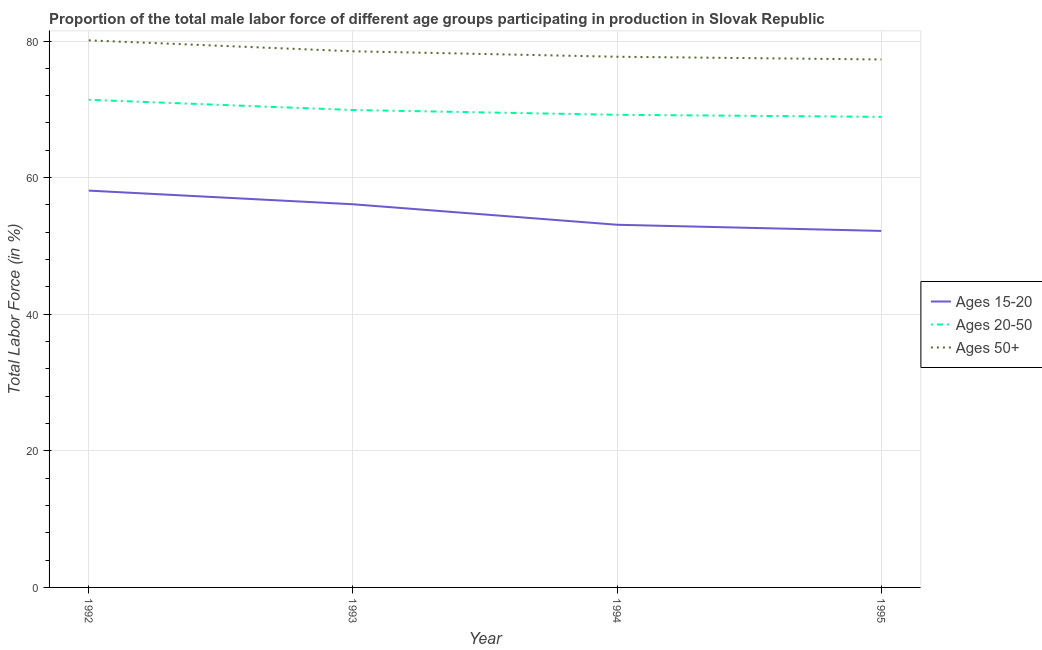Is the number of lines equal to the number of legend labels?
Offer a very short reply. Yes. What is the percentage of male labor force within the age group 20-50 in 1993?
Your response must be concise. 69.9. Across all years, what is the maximum percentage of male labor force within the age group 15-20?
Offer a terse response. 58.1. Across all years, what is the minimum percentage of male labor force above age 50?
Ensure brevity in your answer.  77.3. In which year was the percentage of male labor force within the age group 15-20 minimum?
Offer a very short reply. 1995. What is the total percentage of male labor force within the age group 20-50 in the graph?
Make the answer very short. 279.4. What is the difference between the percentage of male labor force within the age group 20-50 in 1993 and that in 1994?
Your response must be concise. 0.7. What is the difference between the percentage of male labor force within the age group 20-50 in 1994 and the percentage of male labor force above age 50 in 1993?
Your response must be concise. -9.3. What is the average percentage of male labor force within the age group 15-20 per year?
Your answer should be compact. 54.87. In the year 1995, what is the difference between the percentage of male labor force above age 50 and percentage of male labor force within the age group 15-20?
Your answer should be very brief. 25.1. What is the ratio of the percentage of male labor force within the age group 20-50 in 1993 to that in 1994?
Give a very brief answer. 1.01. What is the difference between the highest and the second highest percentage of male labor force within the age group 20-50?
Keep it short and to the point. 1.5. What is the difference between the highest and the lowest percentage of male labor force within the age group 15-20?
Make the answer very short. 5.9. In how many years, is the percentage of male labor force within the age group 20-50 greater than the average percentage of male labor force within the age group 20-50 taken over all years?
Your response must be concise. 2. How many lines are there?
Your response must be concise. 3. What is the difference between two consecutive major ticks on the Y-axis?
Provide a succinct answer. 20. Are the values on the major ticks of Y-axis written in scientific E-notation?
Ensure brevity in your answer.  No. How many legend labels are there?
Provide a succinct answer. 3. How are the legend labels stacked?
Give a very brief answer. Vertical. What is the title of the graph?
Offer a very short reply. Proportion of the total male labor force of different age groups participating in production in Slovak Republic. Does "Hydroelectric sources" appear as one of the legend labels in the graph?
Make the answer very short. No. What is the label or title of the X-axis?
Offer a terse response. Year. What is the label or title of the Y-axis?
Provide a succinct answer. Total Labor Force (in %). What is the Total Labor Force (in %) of Ages 15-20 in 1992?
Your answer should be very brief. 58.1. What is the Total Labor Force (in %) of Ages 20-50 in 1992?
Make the answer very short. 71.4. What is the Total Labor Force (in %) in Ages 50+ in 1992?
Your response must be concise. 80.1. What is the Total Labor Force (in %) in Ages 15-20 in 1993?
Give a very brief answer. 56.1. What is the Total Labor Force (in %) in Ages 20-50 in 1993?
Your response must be concise. 69.9. What is the Total Labor Force (in %) in Ages 50+ in 1993?
Your answer should be compact. 78.5. What is the Total Labor Force (in %) in Ages 15-20 in 1994?
Ensure brevity in your answer.  53.1. What is the Total Labor Force (in %) in Ages 20-50 in 1994?
Provide a succinct answer. 69.2. What is the Total Labor Force (in %) of Ages 50+ in 1994?
Provide a succinct answer. 77.7. What is the Total Labor Force (in %) of Ages 15-20 in 1995?
Make the answer very short. 52.2. What is the Total Labor Force (in %) of Ages 20-50 in 1995?
Provide a short and direct response. 68.9. What is the Total Labor Force (in %) in Ages 50+ in 1995?
Offer a terse response. 77.3. Across all years, what is the maximum Total Labor Force (in %) of Ages 15-20?
Keep it short and to the point. 58.1. Across all years, what is the maximum Total Labor Force (in %) of Ages 20-50?
Offer a very short reply. 71.4. Across all years, what is the maximum Total Labor Force (in %) of Ages 50+?
Provide a short and direct response. 80.1. Across all years, what is the minimum Total Labor Force (in %) of Ages 15-20?
Provide a succinct answer. 52.2. Across all years, what is the minimum Total Labor Force (in %) of Ages 20-50?
Offer a very short reply. 68.9. Across all years, what is the minimum Total Labor Force (in %) in Ages 50+?
Make the answer very short. 77.3. What is the total Total Labor Force (in %) in Ages 15-20 in the graph?
Give a very brief answer. 219.5. What is the total Total Labor Force (in %) of Ages 20-50 in the graph?
Your answer should be very brief. 279.4. What is the total Total Labor Force (in %) of Ages 50+ in the graph?
Offer a very short reply. 313.6. What is the difference between the Total Labor Force (in %) in Ages 20-50 in 1992 and that in 1993?
Make the answer very short. 1.5. What is the difference between the Total Labor Force (in %) in Ages 50+ in 1992 and that in 1993?
Your answer should be compact. 1.6. What is the difference between the Total Labor Force (in %) of Ages 15-20 in 1992 and that in 1995?
Provide a succinct answer. 5.9. What is the difference between the Total Labor Force (in %) of Ages 50+ in 1992 and that in 1995?
Your response must be concise. 2.8. What is the difference between the Total Labor Force (in %) in Ages 15-20 in 1993 and that in 1994?
Your answer should be compact. 3. What is the difference between the Total Labor Force (in %) in Ages 20-50 in 1993 and that in 1994?
Ensure brevity in your answer.  0.7. What is the difference between the Total Labor Force (in %) of Ages 50+ in 1993 and that in 1994?
Give a very brief answer. 0.8. What is the difference between the Total Labor Force (in %) of Ages 15-20 in 1994 and that in 1995?
Offer a very short reply. 0.9. What is the difference between the Total Labor Force (in %) of Ages 50+ in 1994 and that in 1995?
Your response must be concise. 0.4. What is the difference between the Total Labor Force (in %) in Ages 15-20 in 1992 and the Total Labor Force (in %) in Ages 50+ in 1993?
Make the answer very short. -20.4. What is the difference between the Total Labor Force (in %) in Ages 20-50 in 1992 and the Total Labor Force (in %) in Ages 50+ in 1993?
Your answer should be compact. -7.1. What is the difference between the Total Labor Force (in %) of Ages 15-20 in 1992 and the Total Labor Force (in %) of Ages 50+ in 1994?
Your answer should be compact. -19.6. What is the difference between the Total Labor Force (in %) in Ages 15-20 in 1992 and the Total Labor Force (in %) in Ages 50+ in 1995?
Offer a terse response. -19.2. What is the difference between the Total Labor Force (in %) in Ages 15-20 in 1993 and the Total Labor Force (in %) in Ages 50+ in 1994?
Keep it short and to the point. -21.6. What is the difference between the Total Labor Force (in %) of Ages 15-20 in 1993 and the Total Labor Force (in %) of Ages 20-50 in 1995?
Your answer should be very brief. -12.8. What is the difference between the Total Labor Force (in %) in Ages 15-20 in 1993 and the Total Labor Force (in %) in Ages 50+ in 1995?
Offer a terse response. -21.2. What is the difference between the Total Labor Force (in %) of Ages 20-50 in 1993 and the Total Labor Force (in %) of Ages 50+ in 1995?
Provide a short and direct response. -7.4. What is the difference between the Total Labor Force (in %) in Ages 15-20 in 1994 and the Total Labor Force (in %) in Ages 20-50 in 1995?
Ensure brevity in your answer.  -15.8. What is the difference between the Total Labor Force (in %) of Ages 15-20 in 1994 and the Total Labor Force (in %) of Ages 50+ in 1995?
Provide a succinct answer. -24.2. What is the difference between the Total Labor Force (in %) in Ages 20-50 in 1994 and the Total Labor Force (in %) in Ages 50+ in 1995?
Your response must be concise. -8.1. What is the average Total Labor Force (in %) of Ages 15-20 per year?
Provide a succinct answer. 54.88. What is the average Total Labor Force (in %) in Ages 20-50 per year?
Give a very brief answer. 69.85. What is the average Total Labor Force (in %) of Ages 50+ per year?
Ensure brevity in your answer.  78.4. In the year 1993, what is the difference between the Total Labor Force (in %) of Ages 15-20 and Total Labor Force (in %) of Ages 20-50?
Provide a succinct answer. -13.8. In the year 1993, what is the difference between the Total Labor Force (in %) of Ages 15-20 and Total Labor Force (in %) of Ages 50+?
Offer a terse response. -22.4. In the year 1994, what is the difference between the Total Labor Force (in %) of Ages 15-20 and Total Labor Force (in %) of Ages 20-50?
Offer a very short reply. -16.1. In the year 1994, what is the difference between the Total Labor Force (in %) of Ages 15-20 and Total Labor Force (in %) of Ages 50+?
Offer a terse response. -24.6. In the year 1994, what is the difference between the Total Labor Force (in %) of Ages 20-50 and Total Labor Force (in %) of Ages 50+?
Provide a short and direct response. -8.5. In the year 1995, what is the difference between the Total Labor Force (in %) of Ages 15-20 and Total Labor Force (in %) of Ages 20-50?
Keep it short and to the point. -16.7. In the year 1995, what is the difference between the Total Labor Force (in %) of Ages 15-20 and Total Labor Force (in %) of Ages 50+?
Your answer should be very brief. -25.1. What is the ratio of the Total Labor Force (in %) of Ages 15-20 in 1992 to that in 1993?
Your answer should be very brief. 1.04. What is the ratio of the Total Labor Force (in %) in Ages 20-50 in 1992 to that in 1993?
Provide a succinct answer. 1.02. What is the ratio of the Total Labor Force (in %) in Ages 50+ in 1992 to that in 1993?
Ensure brevity in your answer.  1.02. What is the ratio of the Total Labor Force (in %) of Ages 15-20 in 1992 to that in 1994?
Offer a very short reply. 1.09. What is the ratio of the Total Labor Force (in %) of Ages 20-50 in 1992 to that in 1994?
Keep it short and to the point. 1.03. What is the ratio of the Total Labor Force (in %) in Ages 50+ in 1992 to that in 1994?
Keep it short and to the point. 1.03. What is the ratio of the Total Labor Force (in %) in Ages 15-20 in 1992 to that in 1995?
Offer a very short reply. 1.11. What is the ratio of the Total Labor Force (in %) in Ages 20-50 in 1992 to that in 1995?
Offer a terse response. 1.04. What is the ratio of the Total Labor Force (in %) of Ages 50+ in 1992 to that in 1995?
Your answer should be very brief. 1.04. What is the ratio of the Total Labor Force (in %) in Ages 15-20 in 1993 to that in 1994?
Provide a short and direct response. 1.06. What is the ratio of the Total Labor Force (in %) of Ages 50+ in 1993 to that in 1994?
Offer a very short reply. 1.01. What is the ratio of the Total Labor Force (in %) of Ages 15-20 in 1993 to that in 1995?
Your response must be concise. 1.07. What is the ratio of the Total Labor Force (in %) of Ages 20-50 in 1993 to that in 1995?
Make the answer very short. 1.01. What is the ratio of the Total Labor Force (in %) of Ages 50+ in 1993 to that in 1995?
Your response must be concise. 1.02. What is the ratio of the Total Labor Force (in %) of Ages 15-20 in 1994 to that in 1995?
Your response must be concise. 1.02. What is the difference between the highest and the lowest Total Labor Force (in %) of Ages 15-20?
Ensure brevity in your answer.  5.9. What is the difference between the highest and the lowest Total Labor Force (in %) of Ages 50+?
Provide a short and direct response. 2.8. 